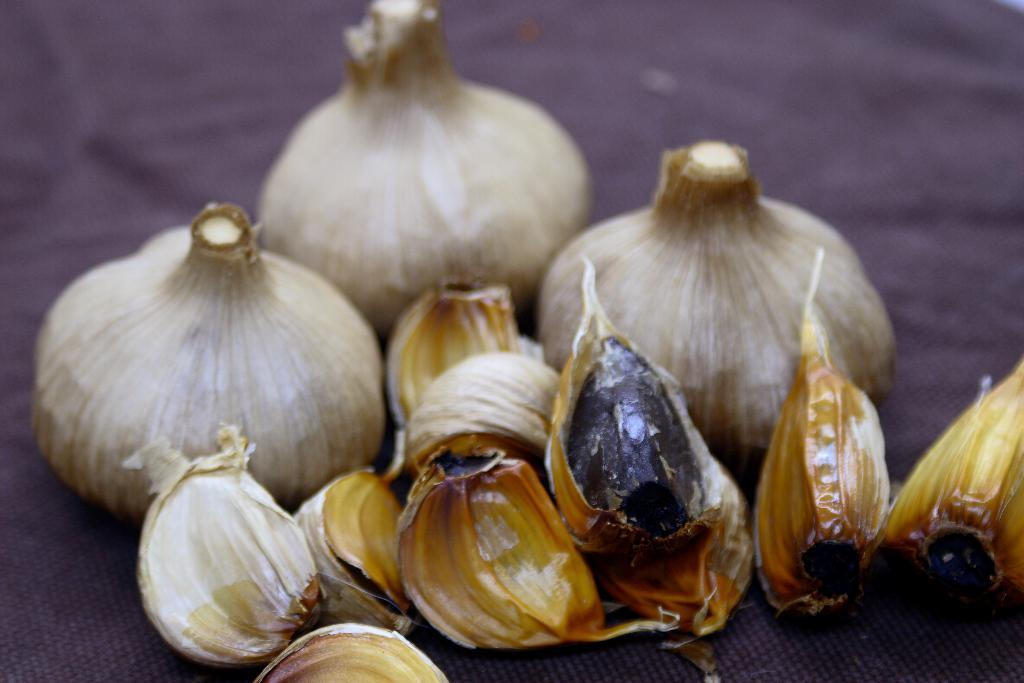What type of food items are present in the image? There are garlic bulbs and garlic cloves in the image. How many garlic bulbs are untouched in the image? Three of the garlic bulbs are untouched in the image. What distance must be traveled to reach the nearest sign from the garlic bulbs in the image? There is no sign present in the image, so it is not possible to determine the distance to the nearest sign. 